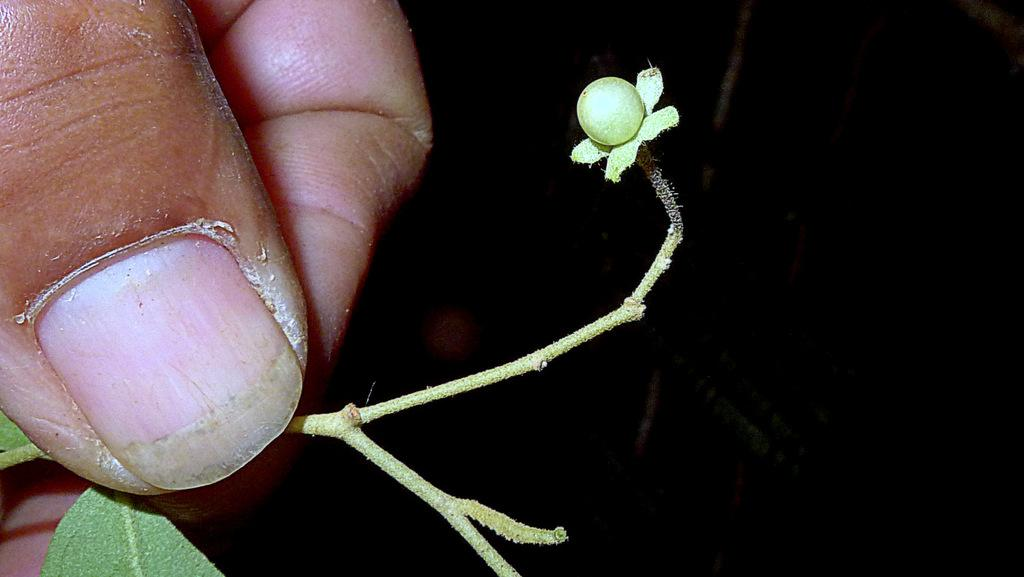What is the main subject of the image? The main subject of the image is a hand holding a small stem of a plant. Can you describe the background of the image? The background of the image is dark. What birthday message is written in the caption of the image? There is no caption present in the image, and therefore no birthday message can be found. 